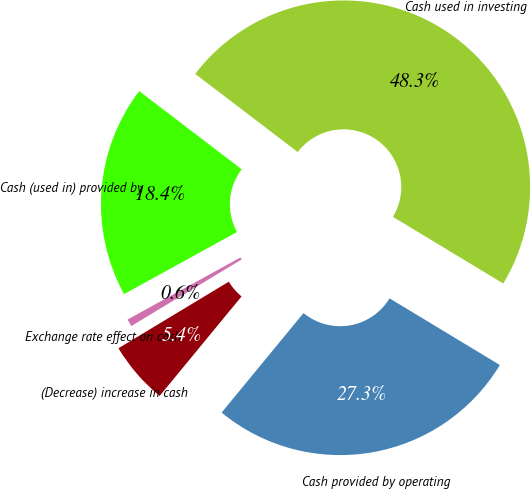Convert chart. <chart><loc_0><loc_0><loc_500><loc_500><pie_chart><fcel>Cash provided by operating<fcel>Cash used in investing<fcel>Cash (used in) provided by<fcel>Exchange rate effect on cash<fcel>(Decrease) increase in cash<nl><fcel>27.31%<fcel>48.28%<fcel>18.37%<fcel>0.64%<fcel>5.4%<nl></chart> 